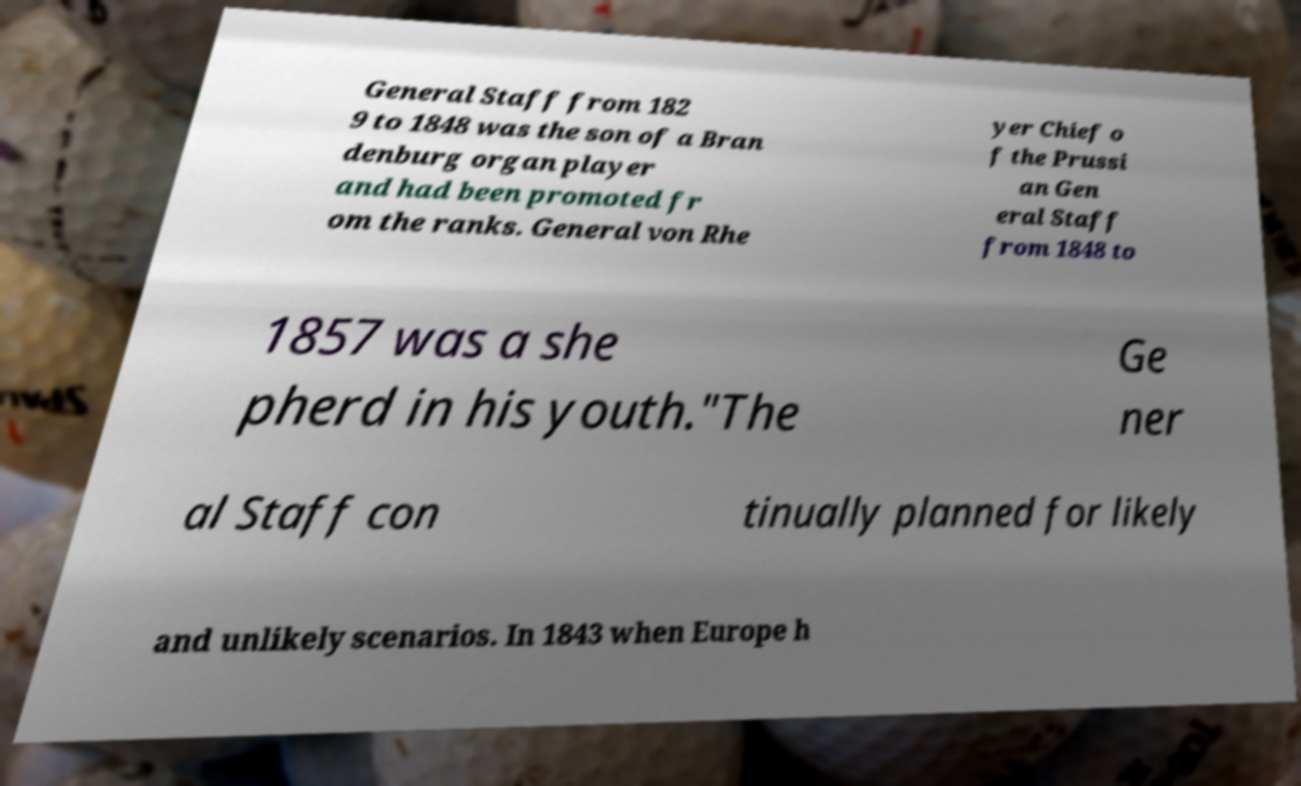For documentation purposes, I need the text within this image transcribed. Could you provide that? General Staff from 182 9 to 1848 was the son of a Bran denburg organ player and had been promoted fr om the ranks. General von Rhe yer Chief o f the Prussi an Gen eral Staff from 1848 to 1857 was a she pherd in his youth."The Ge ner al Staff con tinually planned for likely and unlikely scenarios. In 1843 when Europe h 